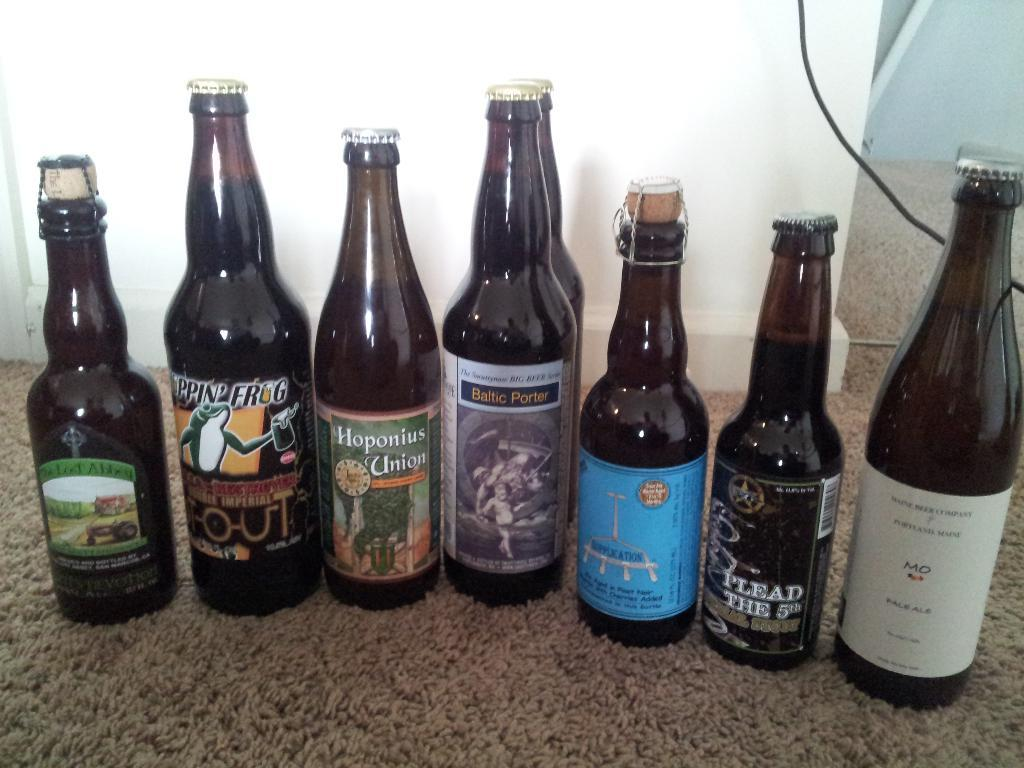<image>
Present a compact description of the photo's key features. A Plead the 5th brand of beer is included in a row of bottles. 